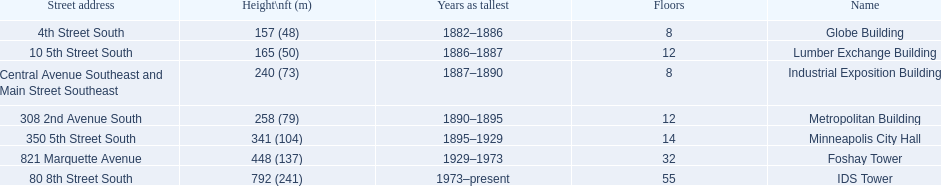What are the tallest buildings in minneapolis? Globe Building, Lumber Exchange Building, Industrial Exposition Building, Metropolitan Building, Minneapolis City Hall, Foshay Tower, IDS Tower. What is the height of the metropolitan building? 258 (79). What is the height of the lumber exchange building? 165 (50). Of those two which is taller? Metropolitan Building. 